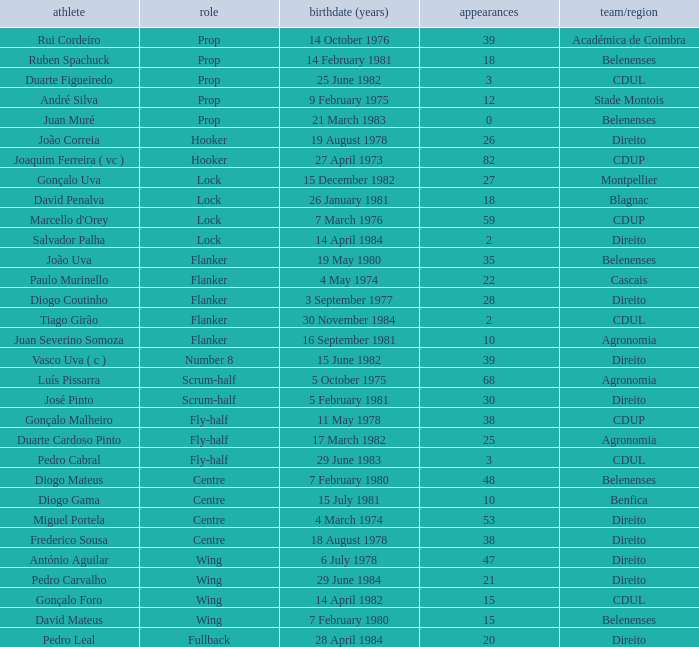Which Club/province has a Player of david penalva? Blagnac. 